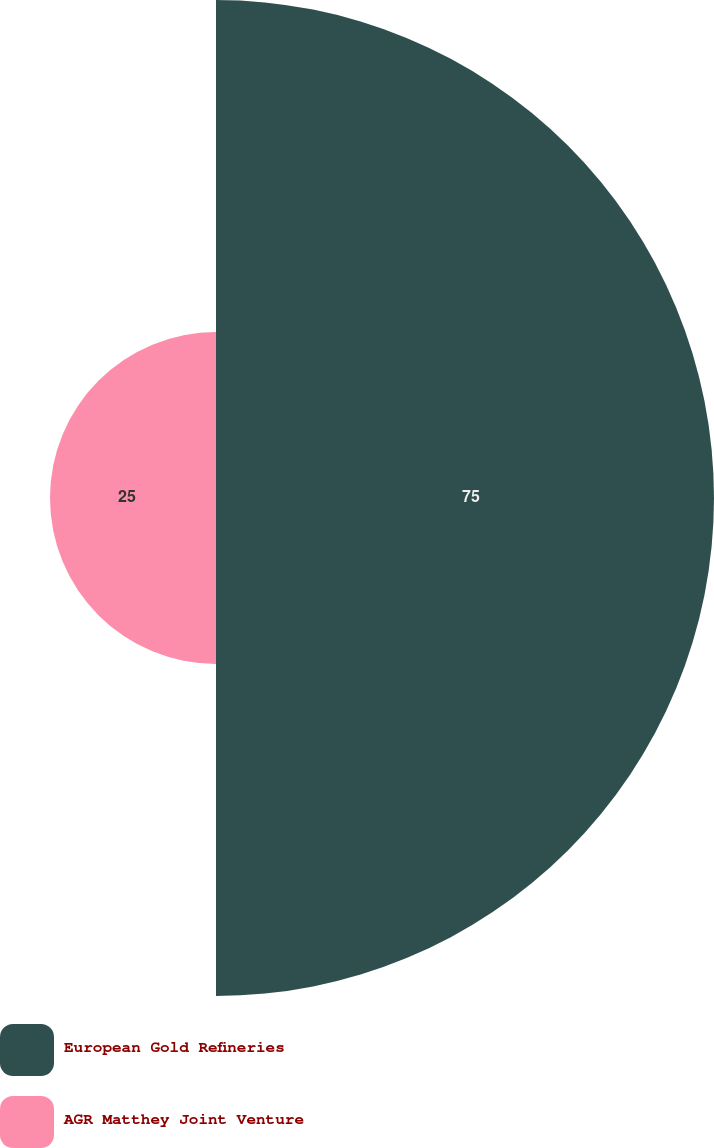Convert chart. <chart><loc_0><loc_0><loc_500><loc_500><pie_chart><fcel>European Gold Refineries<fcel>AGR Matthey Joint Venture<nl><fcel>75.0%<fcel>25.0%<nl></chart> 